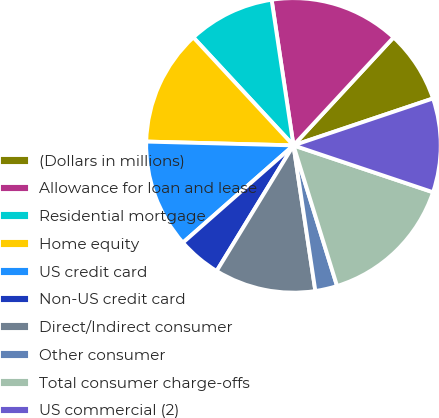Convert chart to OTSL. <chart><loc_0><loc_0><loc_500><loc_500><pie_chart><fcel>(Dollars in millions)<fcel>Allowance for loan and lease<fcel>Residential mortgage<fcel>Home equity<fcel>US credit card<fcel>Non-US credit card<fcel>Direct/Indirect consumer<fcel>Other consumer<fcel>Total consumer charge-offs<fcel>US commercial (2)<nl><fcel>7.94%<fcel>14.27%<fcel>9.53%<fcel>12.69%<fcel>11.9%<fcel>4.78%<fcel>11.11%<fcel>2.41%<fcel>15.06%<fcel>10.32%<nl></chart> 